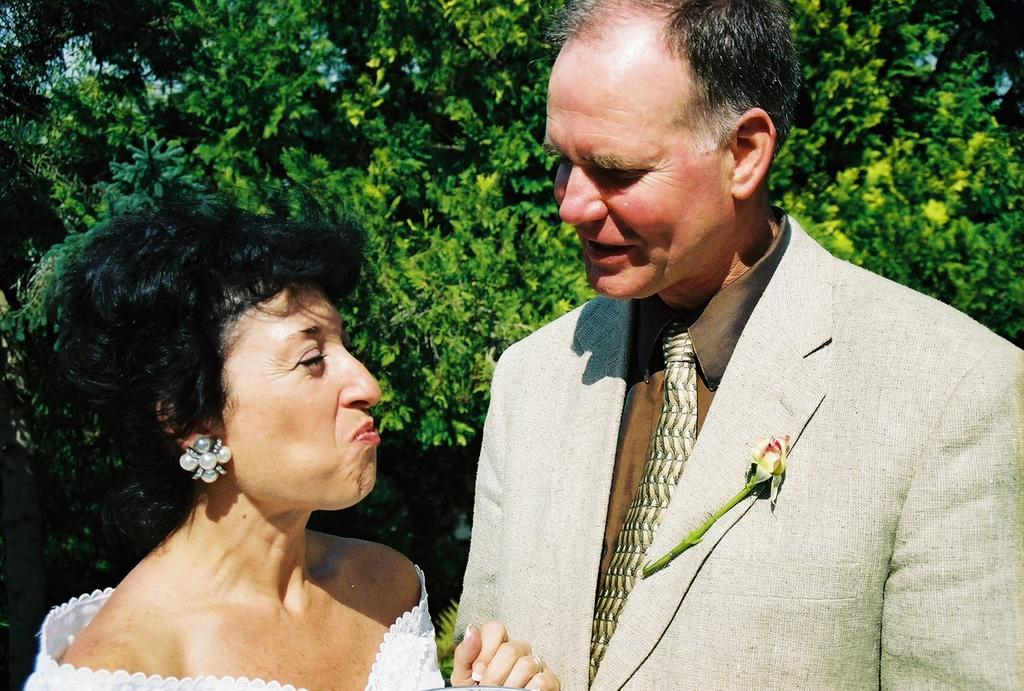How many people are in the image? There are two people in the image, a man and a woman. Where are the man and woman located in the image? The man and woman are in the center of the image. What can be seen in the background of the image? There is greenery in the background of the image. What type of stone is the man holding in the image? There is no stone present in the image; the man and woman are the only subjects visible. 